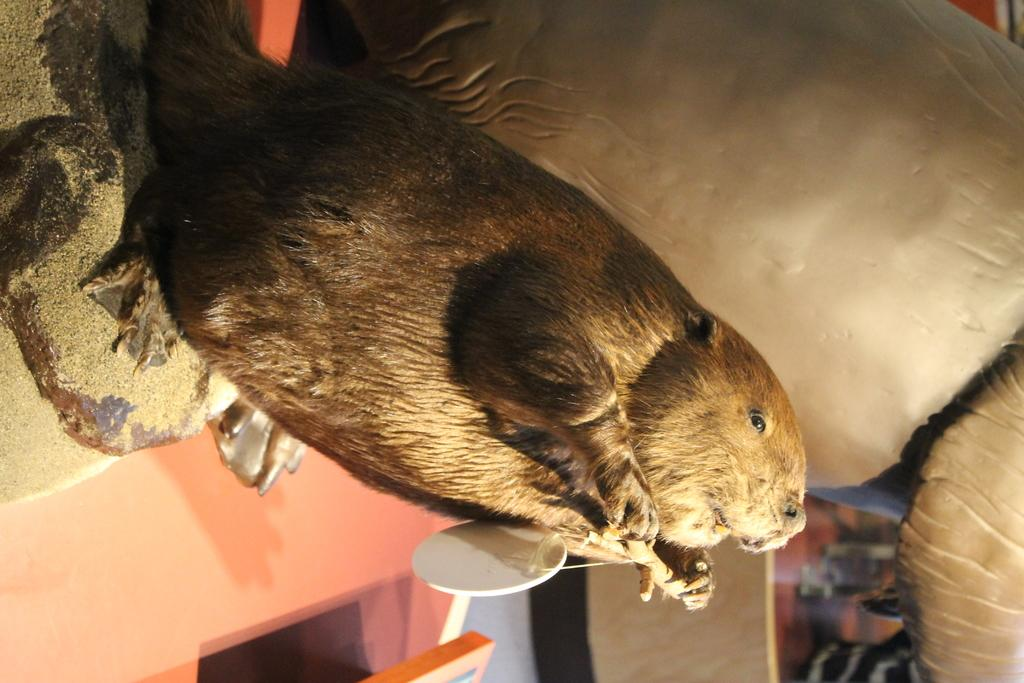What is the main subject of the image? The main subject of the image is a mice statue. Where is the mice statue located? The mice statue is on top of a table. What else can be seen near the mice statue? There is an object beside the statue. What type of sweater is the mom wearing in the image? There is no mom or sweater present in the image; it features a mice statue on a table with an object beside it. 